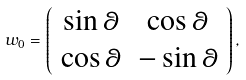<formula> <loc_0><loc_0><loc_500><loc_500>w _ { 0 } = \left ( \begin{array} { c c } \sin \theta & \cos \theta \\ \cos \theta & - \sin \theta \end{array} \right ) ,</formula> 